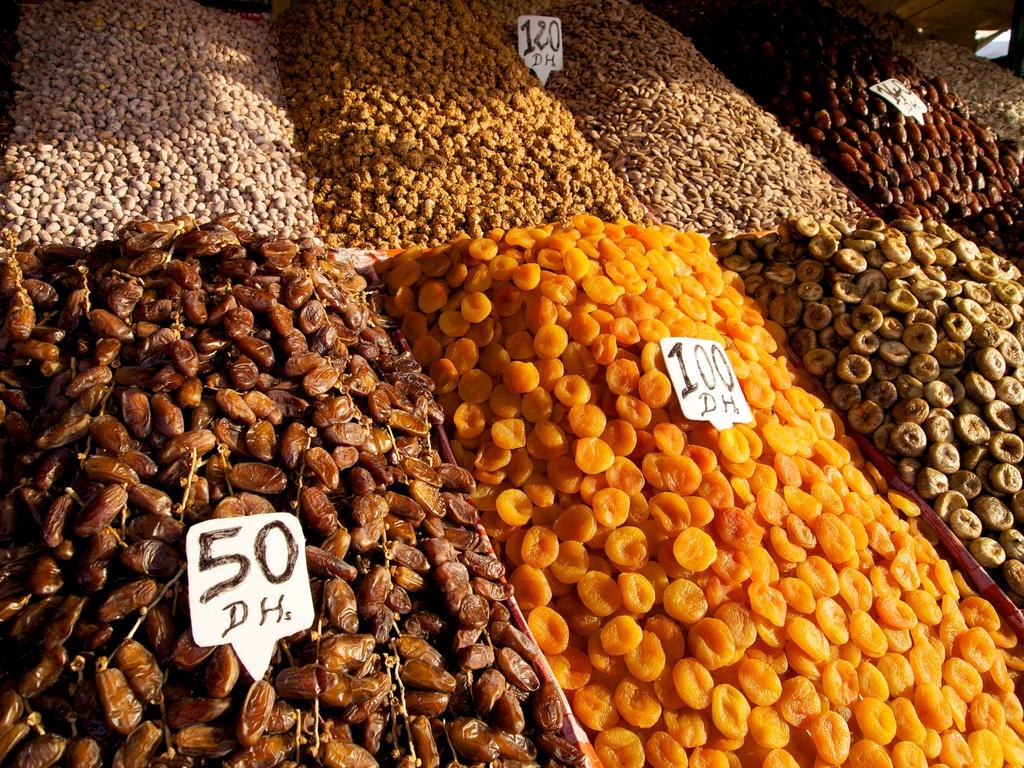What type of food items are present in the image? There are different types of dry fruits in the image. Where are the dry fruits located in the image? The dry fruits are in the middle of the image. What other living creatures can be seen in the image? There are rare birds in the image. How are the rare birds positioned in relation to the dry fruits? The rare birds are kept on the dry fruits. What type of apparatus is used to cook the turkey in the image? There is no turkey or cooking apparatus present in the image. 